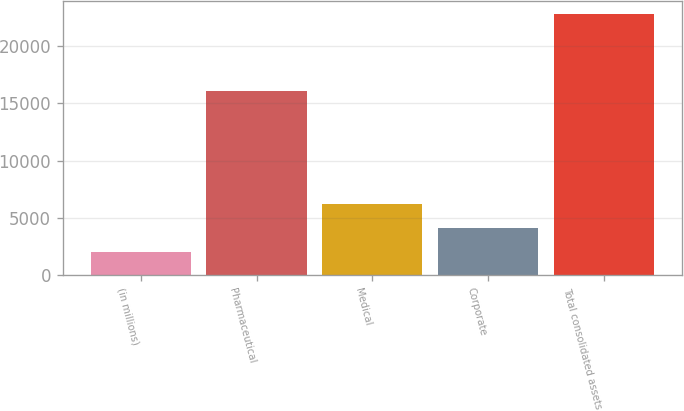<chart> <loc_0><loc_0><loc_500><loc_500><bar_chart><fcel>(in millions)<fcel>Pharmaceutical<fcel>Medical<fcel>Corporate<fcel>Total consolidated assets<nl><fcel>2011<fcel>16125.9<fcel>6177.98<fcel>4094.49<fcel>22845.9<nl></chart> 